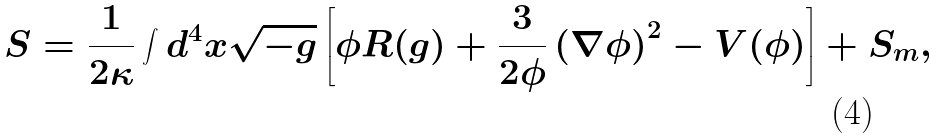Convert formula to latex. <formula><loc_0><loc_0><loc_500><loc_500>S = \frac { 1 } { 2 \kappa } \int d ^ { 4 } x \sqrt { - g } \left [ \phi R ( g ) + \frac { 3 } { 2 \phi } \left ( \nabla \phi \right ) ^ { 2 } - V ( \phi ) \right ] + S _ { m } ,</formula> 